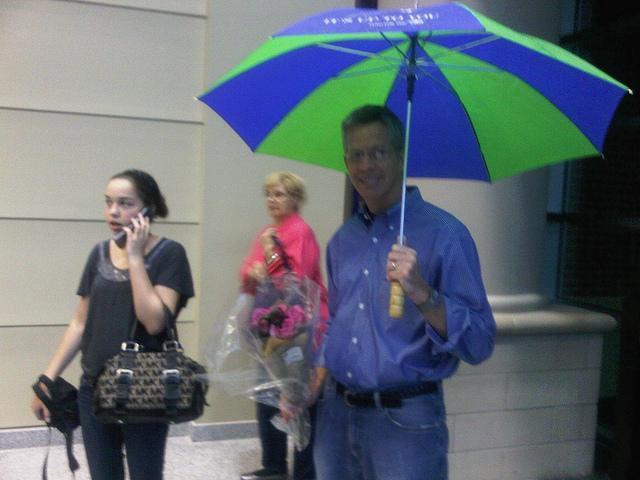How many people in this picture are carrying bags?
Give a very brief answer. 2. How many people are visible?
Give a very brief answer. 3. How many giraffes are leaning over the woman's left shoulder?
Give a very brief answer. 0. 